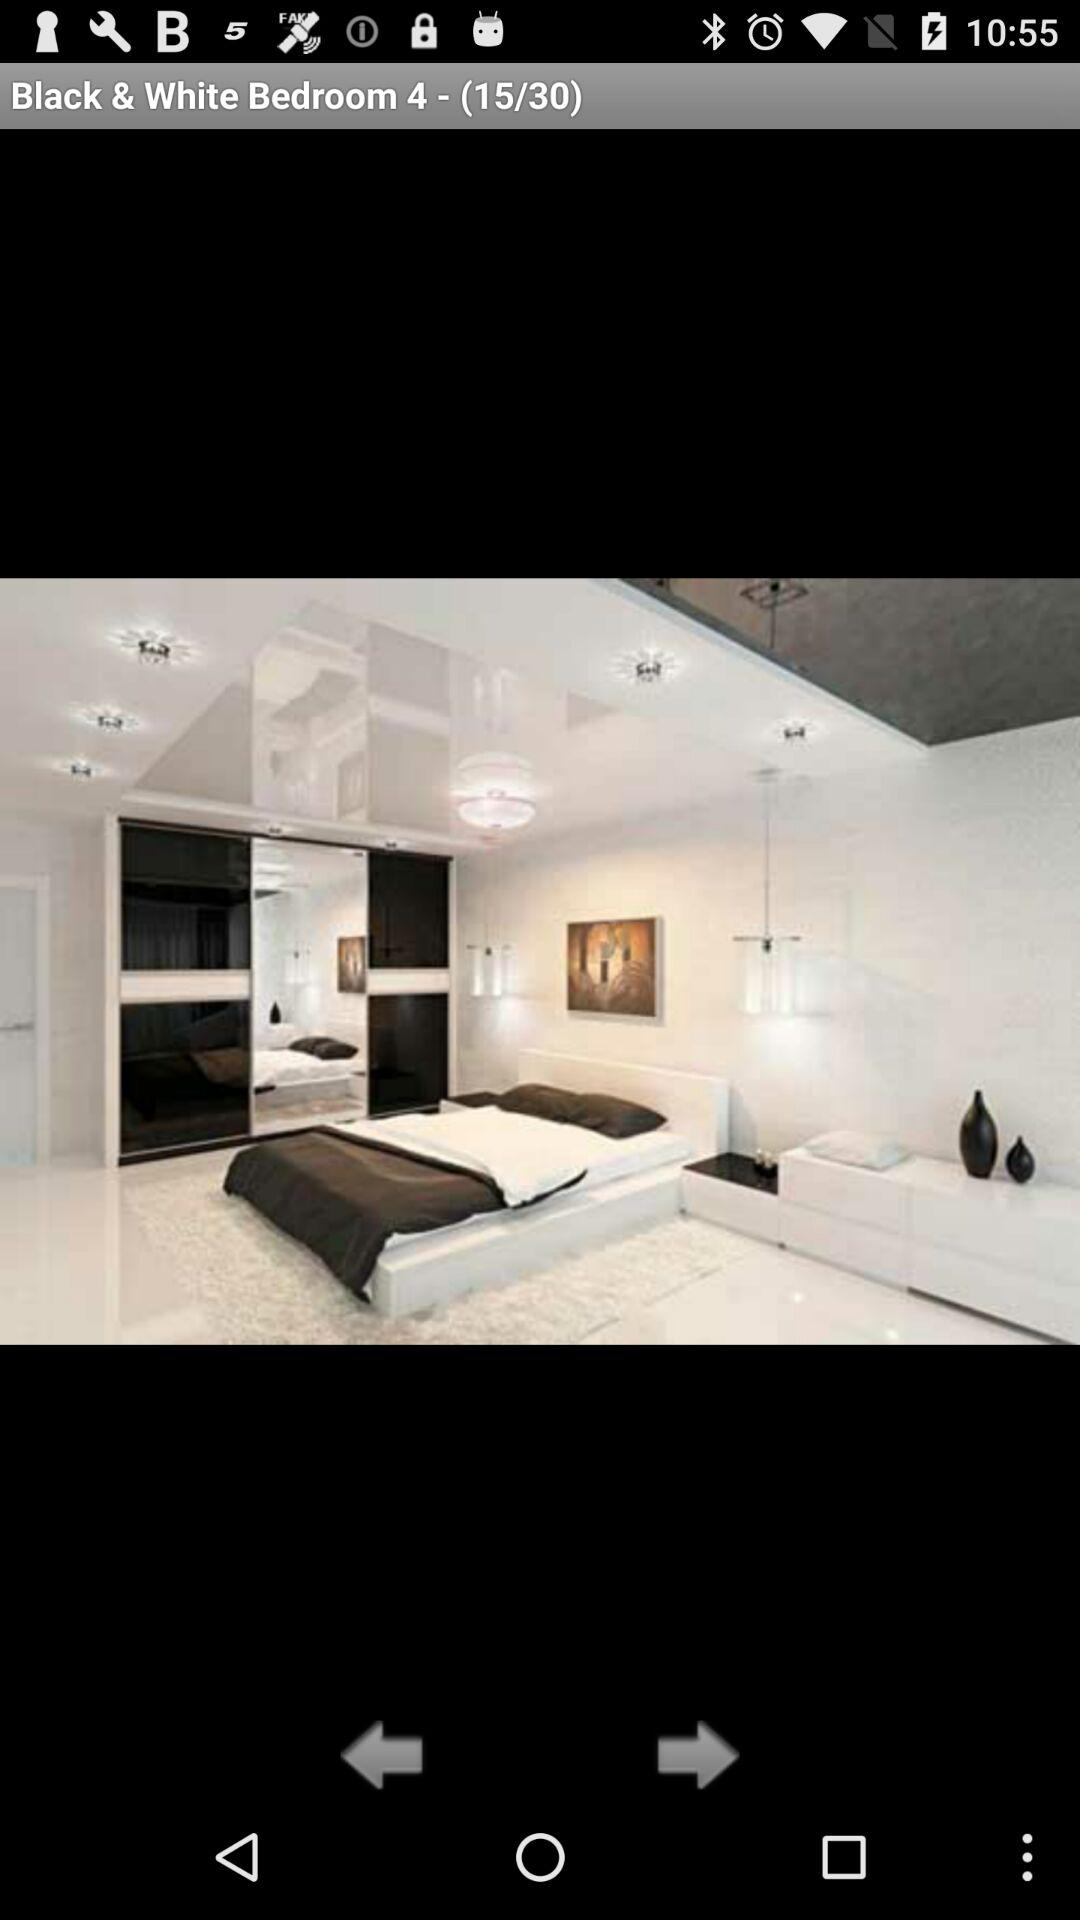Who took this photo?
When the provided information is insufficient, respond with <no answer>. <no answer> 